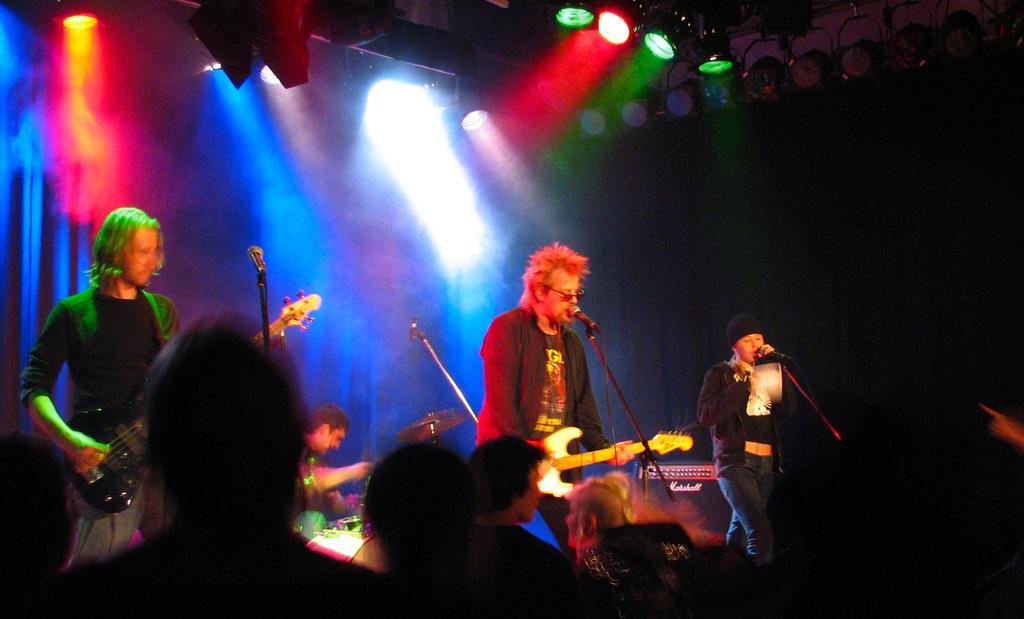Please provide a concise description of this image. In this image I can see three people are standing on the stage. Two are playing the guitars and one is singing a song by holding a mike in his hand. On the bottom of the image I can see few people are looking at those people. On the top of the image I can see few lights. 